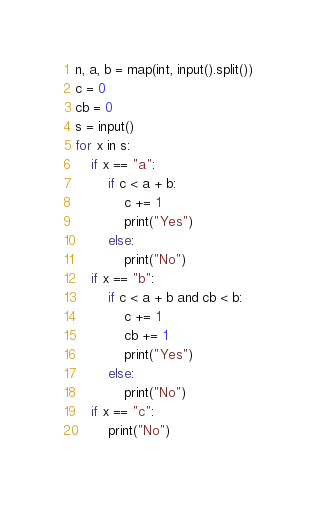Convert code to text. <code><loc_0><loc_0><loc_500><loc_500><_Python_>n, a, b = map(int, input().split())
c = 0
cb = 0
s = input()
for x in s:
    if x == "a":
        if c < a + b:
            c += 1
            print("Yes")
        else:
            print("No")
    if x == "b":
        if c < a + b and cb < b:
            c += 1
            cb += 1
            print("Yes")
        else:
            print("No")
    if x == "c":
        print("No")
</code> 